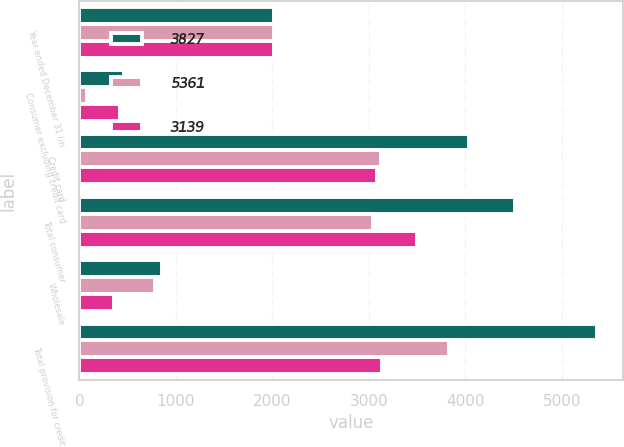<chart> <loc_0><loc_0><loc_500><loc_500><stacked_bar_chart><ecel><fcel>Year ended December 31 (in<fcel>Consumer excluding credit card<fcel>Credit card<fcel>Total consumer<fcel>Wholesale<fcel>Total provision for credit<nl><fcel>3827<fcel>2016<fcel>467<fcel>4042<fcel>4509<fcel>852<fcel>5361<nl><fcel>5361<fcel>2015<fcel>81<fcel>3122<fcel>3041<fcel>786<fcel>3827<nl><fcel>3139<fcel>2014<fcel>419<fcel>3079<fcel>3498<fcel>359<fcel>3139<nl></chart> 